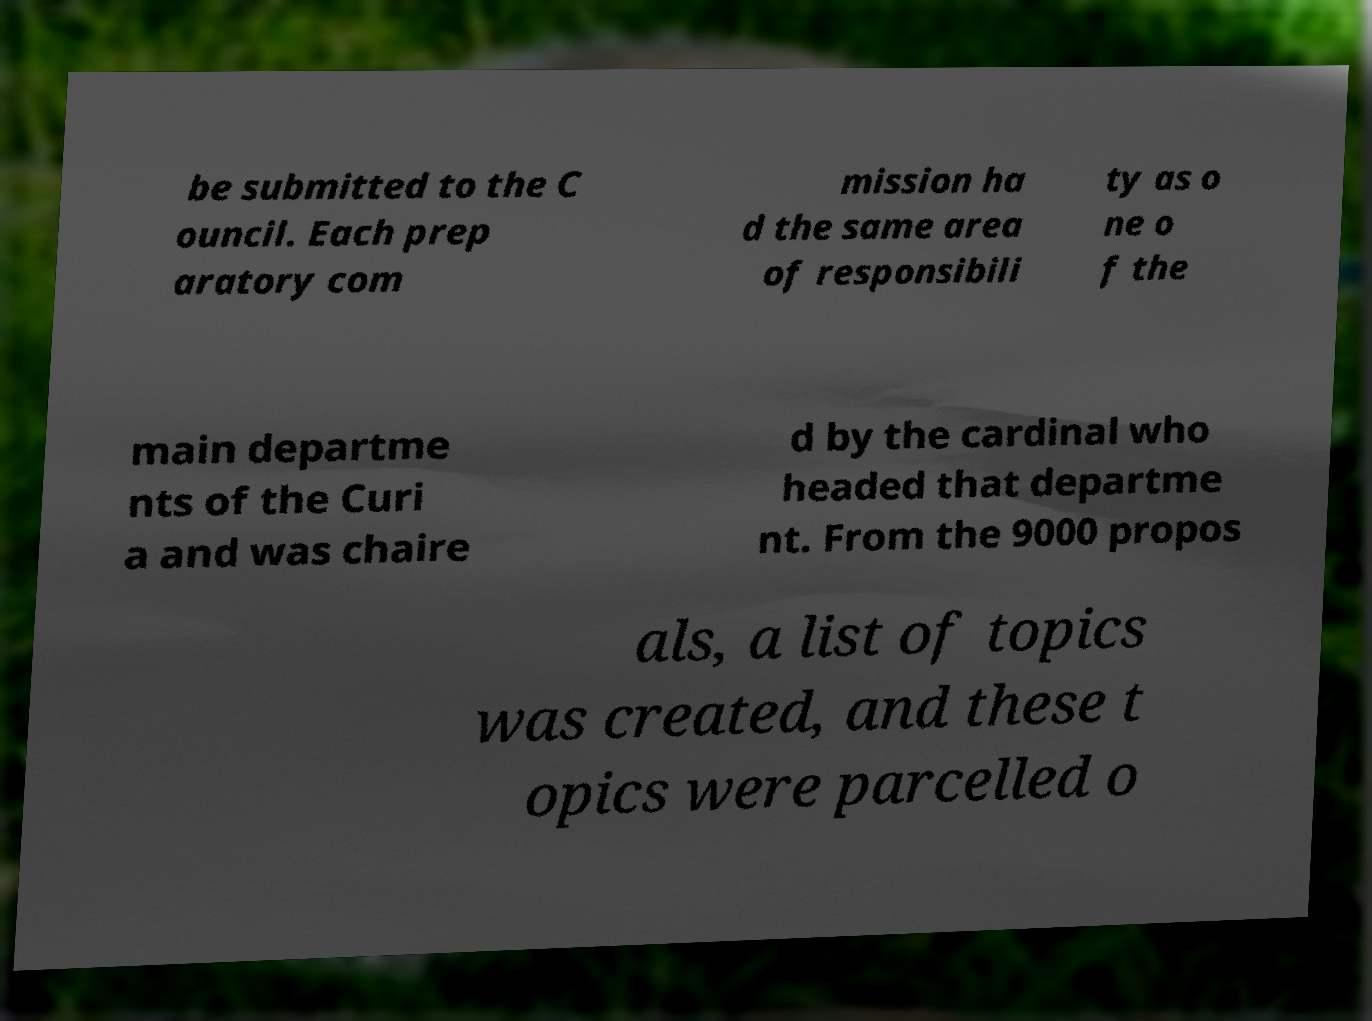Can you accurately transcribe the text from the provided image for me? be submitted to the C ouncil. Each prep aratory com mission ha d the same area of responsibili ty as o ne o f the main departme nts of the Curi a and was chaire d by the cardinal who headed that departme nt. From the 9000 propos als, a list of topics was created, and these t opics were parcelled o 